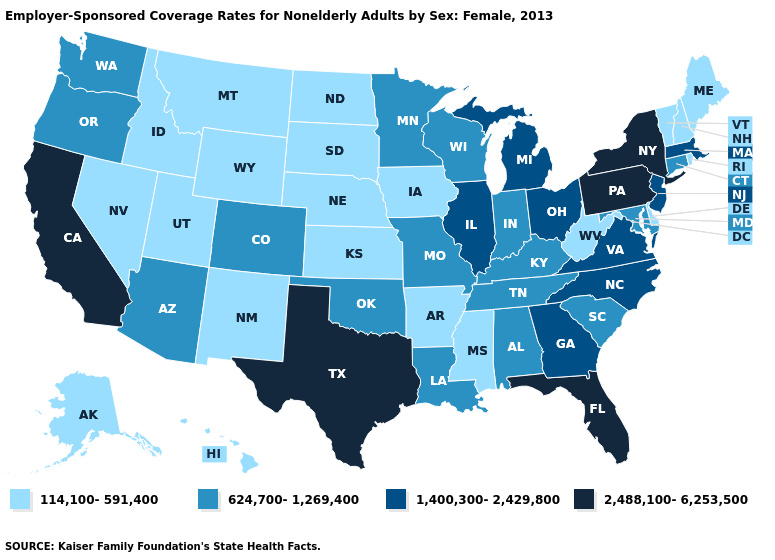Name the states that have a value in the range 1,400,300-2,429,800?
Give a very brief answer. Georgia, Illinois, Massachusetts, Michigan, New Jersey, North Carolina, Ohio, Virginia. Which states have the lowest value in the South?
Be succinct. Arkansas, Delaware, Mississippi, West Virginia. Which states have the highest value in the USA?
Answer briefly. California, Florida, New York, Pennsylvania, Texas. Does Nebraska have a lower value than South Dakota?
Short answer required. No. What is the highest value in the USA?
Concise answer only. 2,488,100-6,253,500. What is the lowest value in the MidWest?
Give a very brief answer. 114,100-591,400. Name the states that have a value in the range 114,100-591,400?
Give a very brief answer. Alaska, Arkansas, Delaware, Hawaii, Idaho, Iowa, Kansas, Maine, Mississippi, Montana, Nebraska, Nevada, New Hampshire, New Mexico, North Dakota, Rhode Island, South Dakota, Utah, Vermont, West Virginia, Wyoming. Name the states that have a value in the range 624,700-1,269,400?
Short answer required. Alabama, Arizona, Colorado, Connecticut, Indiana, Kentucky, Louisiana, Maryland, Minnesota, Missouri, Oklahoma, Oregon, South Carolina, Tennessee, Washington, Wisconsin. What is the value of Pennsylvania?
Write a very short answer. 2,488,100-6,253,500. What is the value of Alabama?
Be succinct. 624,700-1,269,400. What is the lowest value in the South?
Answer briefly. 114,100-591,400. Among the states that border Pennsylvania , does Delaware have the lowest value?
Give a very brief answer. Yes. Does Texas have the lowest value in the South?
Answer briefly. No. Name the states that have a value in the range 2,488,100-6,253,500?
Write a very short answer. California, Florida, New York, Pennsylvania, Texas. What is the value of New York?
Be succinct. 2,488,100-6,253,500. 